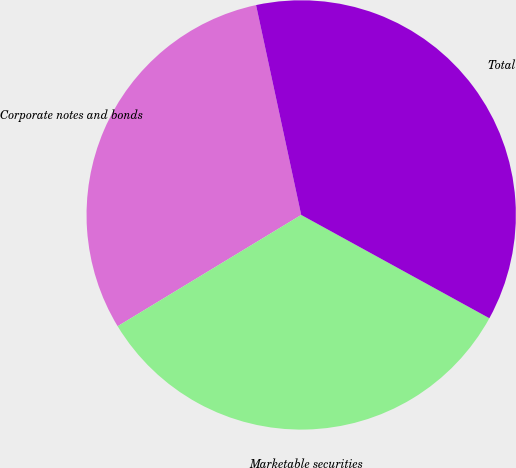<chart> <loc_0><loc_0><loc_500><loc_500><pie_chart><fcel>Corporate notes and bonds<fcel>Marketable securities<fcel>Total<nl><fcel>30.3%<fcel>33.33%<fcel>36.36%<nl></chart> 